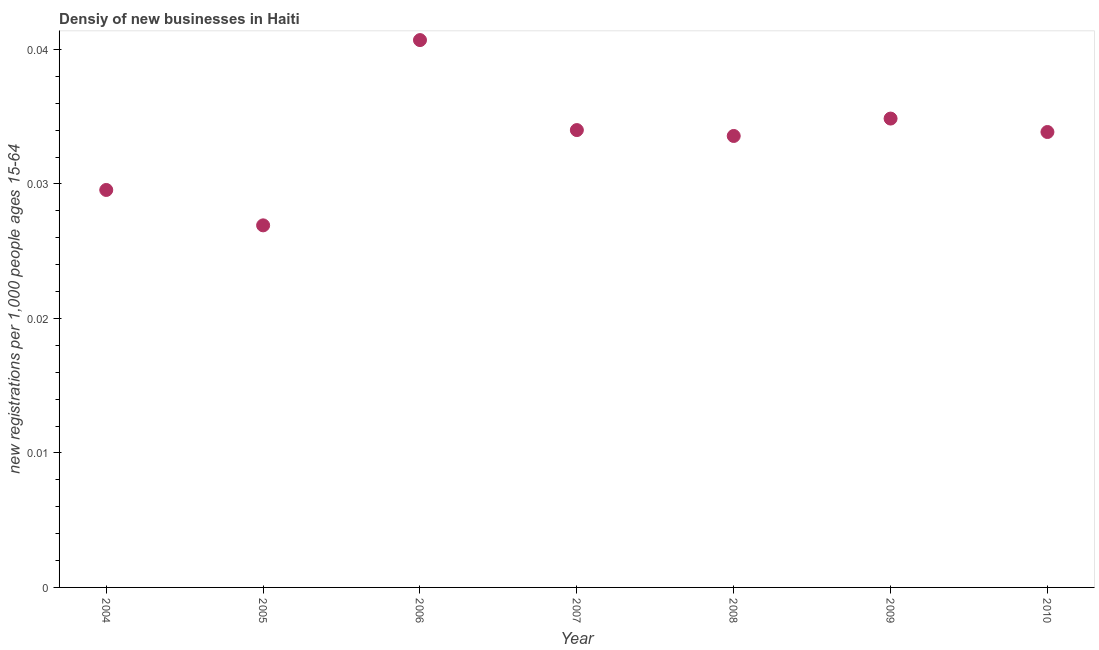What is the density of new business in 2007?
Your response must be concise. 0.03. Across all years, what is the maximum density of new business?
Your answer should be very brief. 0.04. Across all years, what is the minimum density of new business?
Your answer should be very brief. 0.03. What is the sum of the density of new business?
Provide a short and direct response. 0.23. What is the difference between the density of new business in 2005 and 2007?
Provide a succinct answer. -0.01. What is the average density of new business per year?
Give a very brief answer. 0.03. What is the median density of new business?
Keep it short and to the point. 0.03. What is the ratio of the density of new business in 2004 to that in 2007?
Provide a succinct answer. 0.87. What is the difference between the highest and the second highest density of new business?
Your answer should be compact. 0.01. Is the sum of the density of new business in 2007 and 2009 greater than the maximum density of new business across all years?
Give a very brief answer. Yes. What is the difference between the highest and the lowest density of new business?
Offer a terse response. 0.01. In how many years, is the density of new business greater than the average density of new business taken over all years?
Make the answer very short. 5. How many dotlines are there?
Your answer should be very brief. 1. How many years are there in the graph?
Keep it short and to the point. 7. What is the difference between two consecutive major ticks on the Y-axis?
Provide a succinct answer. 0.01. Are the values on the major ticks of Y-axis written in scientific E-notation?
Provide a short and direct response. No. Does the graph contain any zero values?
Offer a terse response. No. What is the title of the graph?
Your answer should be compact. Densiy of new businesses in Haiti. What is the label or title of the X-axis?
Offer a very short reply. Year. What is the label or title of the Y-axis?
Give a very brief answer. New registrations per 1,0 people ages 15-64. What is the new registrations per 1,000 people ages 15-64 in 2004?
Keep it short and to the point. 0.03. What is the new registrations per 1,000 people ages 15-64 in 2005?
Make the answer very short. 0.03. What is the new registrations per 1,000 people ages 15-64 in 2006?
Offer a very short reply. 0.04. What is the new registrations per 1,000 people ages 15-64 in 2007?
Offer a very short reply. 0.03. What is the new registrations per 1,000 people ages 15-64 in 2008?
Your response must be concise. 0.03. What is the new registrations per 1,000 people ages 15-64 in 2009?
Provide a succinct answer. 0.03. What is the new registrations per 1,000 people ages 15-64 in 2010?
Your response must be concise. 0.03. What is the difference between the new registrations per 1,000 people ages 15-64 in 2004 and 2005?
Provide a succinct answer. 0. What is the difference between the new registrations per 1,000 people ages 15-64 in 2004 and 2006?
Your answer should be compact. -0.01. What is the difference between the new registrations per 1,000 people ages 15-64 in 2004 and 2007?
Offer a terse response. -0. What is the difference between the new registrations per 1,000 people ages 15-64 in 2004 and 2008?
Your response must be concise. -0. What is the difference between the new registrations per 1,000 people ages 15-64 in 2004 and 2009?
Your answer should be compact. -0.01. What is the difference between the new registrations per 1,000 people ages 15-64 in 2004 and 2010?
Keep it short and to the point. -0. What is the difference between the new registrations per 1,000 people ages 15-64 in 2005 and 2006?
Offer a terse response. -0.01. What is the difference between the new registrations per 1,000 people ages 15-64 in 2005 and 2007?
Give a very brief answer. -0.01. What is the difference between the new registrations per 1,000 people ages 15-64 in 2005 and 2008?
Ensure brevity in your answer.  -0.01. What is the difference between the new registrations per 1,000 people ages 15-64 in 2005 and 2009?
Offer a terse response. -0.01. What is the difference between the new registrations per 1,000 people ages 15-64 in 2005 and 2010?
Provide a short and direct response. -0.01. What is the difference between the new registrations per 1,000 people ages 15-64 in 2006 and 2007?
Keep it short and to the point. 0.01. What is the difference between the new registrations per 1,000 people ages 15-64 in 2006 and 2008?
Your response must be concise. 0.01. What is the difference between the new registrations per 1,000 people ages 15-64 in 2006 and 2009?
Your answer should be compact. 0.01. What is the difference between the new registrations per 1,000 people ages 15-64 in 2006 and 2010?
Provide a succinct answer. 0.01. What is the difference between the new registrations per 1,000 people ages 15-64 in 2007 and 2008?
Make the answer very short. 0. What is the difference between the new registrations per 1,000 people ages 15-64 in 2007 and 2009?
Ensure brevity in your answer.  -0. What is the difference between the new registrations per 1,000 people ages 15-64 in 2007 and 2010?
Keep it short and to the point. 0. What is the difference between the new registrations per 1,000 people ages 15-64 in 2008 and 2009?
Offer a very short reply. -0. What is the difference between the new registrations per 1,000 people ages 15-64 in 2008 and 2010?
Keep it short and to the point. -0. What is the difference between the new registrations per 1,000 people ages 15-64 in 2009 and 2010?
Offer a terse response. 0. What is the ratio of the new registrations per 1,000 people ages 15-64 in 2004 to that in 2005?
Your answer should be very brief. 1.1. What is the ratio of the new registrations per 1,000 people ages 15-64 in 2004 to that in 2006?
Provide a succinct answer. 0.73. What is the ratio of the new registrations per 1,000 people ages 15-64 in 2004 to that in 2007?
Provide a succinct answer. 0.87. What is the ratio of the new registrations per 1,000 people ages 15-64 in 2004 to that in 2008?
Keep it short and to the point. 0.88. What is the ratio of the new registrations per 1,000 people ages 15-64 in 2004 to that in 2009?
Give a very brief answer. 0.85. What is the ratio of the new registrations per 1,000 people ages 15-64 in 2004 to that in 2010?
Keep it short and to the point. 0.87. What is the ratio of the new registrations per 1,000 people ages 15-64 in 2005 to that in 2006?
Provide a succinct answer. 0.66. What is the ratio of the new registrations per 1,000 people ages 15-64 in 2005 to that in 2007?
Offer a terse response. 0.79. What is the ratio of the new registrations per 1,000 people ages 15-64 in 2005 to that in 2008?
Your answer should be very brief. 0.8. What is the ratio of the new registrations per 1,000 people ages 15-64 in 2005 to that in 2009?
Provide a short and direct response. 0.77. What is the ratio of the new registrations per 1,000 people ages 15-64 in 2005 to that in 2010?
Provide a succinct answer. 0.8. What is the ratio of the new registrations per 1,000 people ages 15-64 in 2006 to that in 2007?
Your answer should be compact. 1.2. What is the ratio of the new registrations per 1,000 people ages 15-64 in 2006 to that in 2008?
Keep it short and to the point. 1.21. What is the ratio of the new registrations per 1,000 people ages 15-64 in 2006 to that in 2009?
Give a very brief answer. 1.17. What is the ratio of the new registrations per 1,000 people ages 15-64 in 2006 to that in 2010?
Your answer should be compact. 1.2. What is the ratio of the new registrations per 1,000 people ages 15-64 in 2007 to that in 2008?
Ensure brevity in your answer.  1.01. What is the ratio of the new registrations per 1,000 people ages 15-64 in 2007 to that in 2009?
Your response must be concise. 0.97. What is the ratio of the new registrations per 1,000 people ages 15-64 in 2007 to that in 2010?
Your response must be concise. 1. What is the ratio of the new registrations per 1,000 people ages 15-64 in 2009 to that in 2010?
Provide a short and direct response. 1.03. 